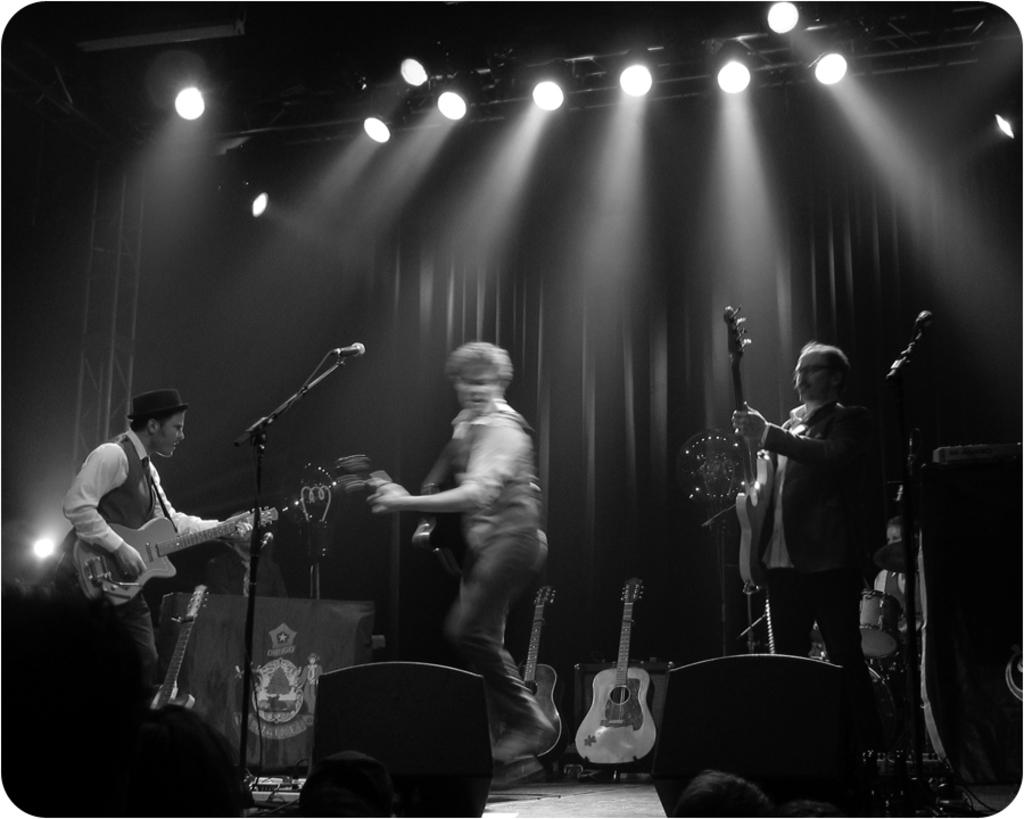What are the men in the image doing? The men in the image are standing and holding guitars. What objects are the men holding in the image? The men are holding guitars in the image. What small animals can be seen in the image? There are mice visible in the image. Can you describe any additional guitars in the image? There are additional guitars in the background of the image. What type of action is the hook performing in the image? There is no hook present in the image, so it is not possible to answer that question. 